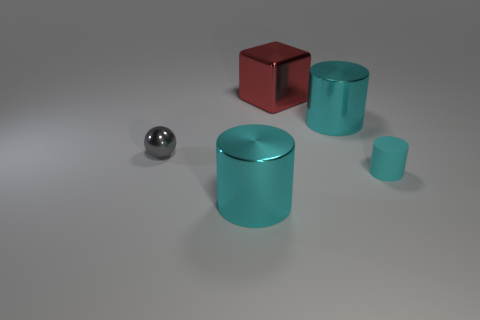There is a cylinder that is left of the big cyan metallic cylinder that is to the right of the red shiny block; how many small cylinders are in front of it? 0 